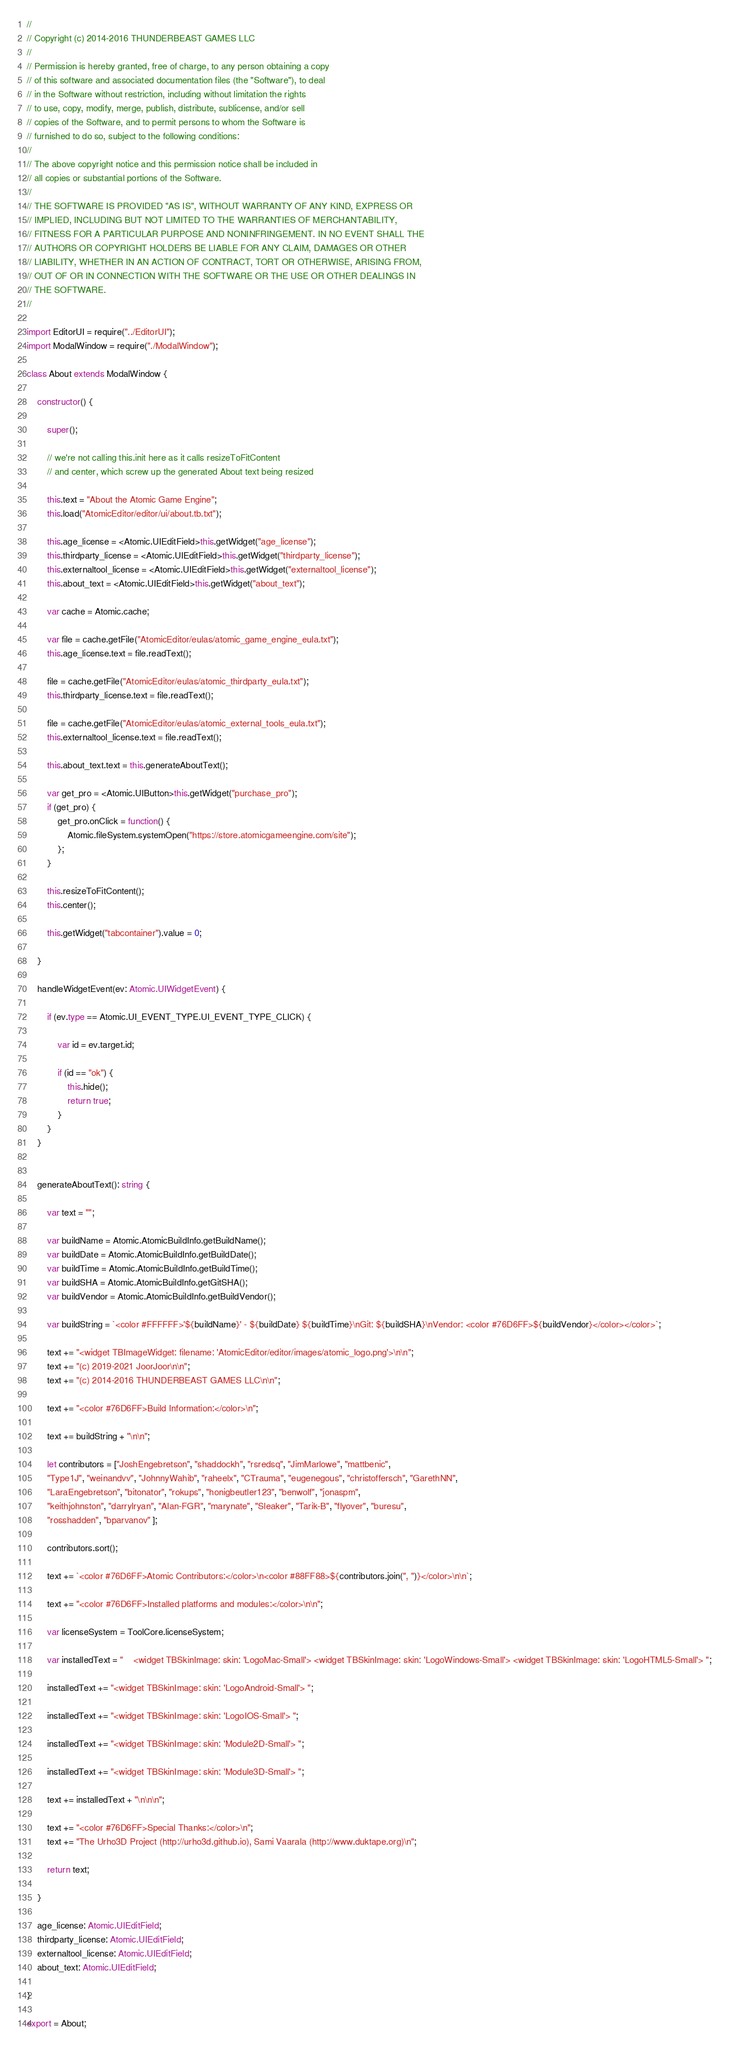Convert code to text. <code><loc_0><loc_0><loc_500><loc_500><_TypeScript_>//
// Copyright (c) 2014-2016 THUNDERBEAST GAMES LLC
//
// Permission is hereby granted, free of charge, to any person obtaining a copy
// of this software and associated documentation files (the "Software"), to deal
// in the Software without restriction, including without limitation the rights
// to use, copy, modify, merge, publish, distribute, sublicense, and/or sell
// copies of the Software, and to permit persons to whom the Software is
// furnished to do so, subject to the following conditions:
//
// The above copyright notice and this permission notice shall be included in
// all copies or substantial portions of the Software.
//
// THE SOFTWARE IS PROVIDED "AS IS", WITHOUT WARRANTY OF ANY KIND, EXPRESS OR
// IMPLIED, INCLUDING BUT NOT LIMITED TO THE WARRANTIES OF MERCHANTABILITY,
// FITNESS FOR A PARTICULAR PURPOSE AND NONINFRINGEMENT. IN NO EVENT SHALL THE
// AUTHORS OR COPYRIGHT HOLDERS BE LIABLE FOR ANY CLAIM, DAMAGES OR OTHER
// LIABILITY, WHETHER IN AN ACTION OF CONTRACT, TORT OR OTHERWISE, ARISING FROM,
// OUT OF OR IN CONNECTION WITH THE SOFTWARE OR THE USE OR OTHER DEALINGS IN
// THE SOFTWARE.
//

import EditorUI = require("../EditorUI");
import ModalWindow = require("./ModalWindow");

class About extends ModalWindow {

    constructor() {

        super();

        // we're not calling this.init here as it calls resizeToFitContent
        // and center, which screw up the generated About text being resized

        this.text = "About the Atomic Game Engine";
        this.load("AtomicEditor/editor/ui/about.tb.txt");

        this.age_license = <Atomic.UIEditField>this.getWidget("age_license");
        this.thirdparty_license = <Atomic.UIEditField>this.getWidget("thirdparty_license");
        this.externaltool_license = <Atomic.UIEditField>this.getWidget("externaltool_license");
        this.about_text = <Atomic.UIEditField>this.getWidget("about_text");

        var cache = Atomic.cache;

        var file = cache.getFile("AtomicEditor/eulas/atomic_game_engine_eula.txt");
        this.age_license.text = file.readText();

        file = cache.getFile("AtomicEditor/eulas/atomic_thirdparty_eula.txt");
        this.thirdparty_license.text = file.readText();

        file = cache.getFile("AtomicEditor/eulas/atomic_external_tools_eula.txt");
        this.externaltool_license.text = file.readText();

        this.about_text.text = this.generateAboutText();

        var get_pro = <Atomic.UIButton>this.getWidget("purchase_pro");
        if (get_pro) {
            get_pro.onClick = function() {
                Atomic.fileSystem.systemOpen("https://store.atomicgameengine.com/site");
            };
        }

        this.resizeToFitContent();
        this.center();

        this.getWidget("tabcontainer").value = 0;

    }

    handleWidgetEvent(ev: Atomic.UIWidgetEvent) {

        if (ev.type == Atomic.UI_EVENT_TYPE.UI_EVENT_TYPE_CLICK) {

            var id = ev.target.id;

            if (id == "ok") {
                this.hide();
                return true;
            }
        }
    }


    generateAboutText(): string {

        var text = "";

        var buildName = Atomic.AtomicBuildInfo.getBuildName();
        var buildDate = Atomic.AtomicBuildInfo.getBuildDate();
        var buildTime = Atomic.AtomicBuildInfo.getBuildTime();
        var buildSHA = Atomic.AtomicBuildInfo.getGitSHA();
        var buildVendor = Atomic.AtomicBuildInfo.getBuildVendor();

        var buildString = `<color #FFFFFF>'${buildName}' - ${buildDate} ${buildTime}\nGit: ${buildSHA}\nVendor: <color #76D6FF>${buildVendor}</color></color>`;

        text += "<widget TBImageWidget: filename: 'AtomicEditor/editor/images/atomic_logo.png'>\n\n";
        text += "(c) 2019-2021 JoorJoor\n\n";
        text += "(c) 2014-2016 THUNDERBEAST GAMES LLC\n\n";

        text += "<color #76D6FF>Build Information:</color>\n";

        text += buildString + "\n\n";

        let contributors = ["JoshEngebretson", "shaddockh", "rsredsq", "JimMarlowe", "mattbenic",
        "Type1J", "weinandvv", "JohnnyWahib", "raheelx", "CTrauma", "eugenegous", "christoffersch", "GarethNN",
        "LaraEngebretson", "bitonator", "rokups", "honigbeutler123", "benwolf", "jonaspm",
        "keithjohnston", "darrylryan", "Alan-FGR", "marynate", "Sleaker", "Tarik-B", "flyover", "buresu",
        "rosshadden", "bparvanov" ];

        contributors.sort();

        text += `<color #76D6FF>Atomic Contributors:</color>\n<color #88FF88>${contributors.join(", ")}</color>\n\n`;

        text += "<color #76D6FF>Installed platforms and modules:</color>\n\n";

        var licenseSystem = ToolCore.licenseSystem;

        var installedText = "    <widget TBSkinImage: skin: 'LogoMac-Small'> <widget TBSkinImage: skin: 'LogoWindows-Small'> <widget TBSkinImage: skin: 'LogoHTML5-Small'> ";

        installedText += "<widget TBSkinImage: skin: 'LogoAndroid-Small'> ";

        installedText += "<widget TBSkinImage: skin: 'LogoIOS-Small'> ";

        installedText += "<widget TBSkinImage: skin: 'Module2D-Small'> ";

        installedText += "<widget TBSkinImage: skin: 'Module3D-Small'> ";

        text += installedText + "\n\n\n";

        text += "<color #76D6FF>Special Thanks:</color>\n";
        text += "The Urho3D Project (http://urho3d.github.io), Sami Vaarala (http://www.duktape.org)\n";

        return text;

    }

    age_license: Atomic.UIEditField;
    thirdparty_license: Atomic.UIEditField;
    externaltool_license: Atomic.UIEditField;
    about_text: Atomic.UIEditField;

}

export = About;
</code> 